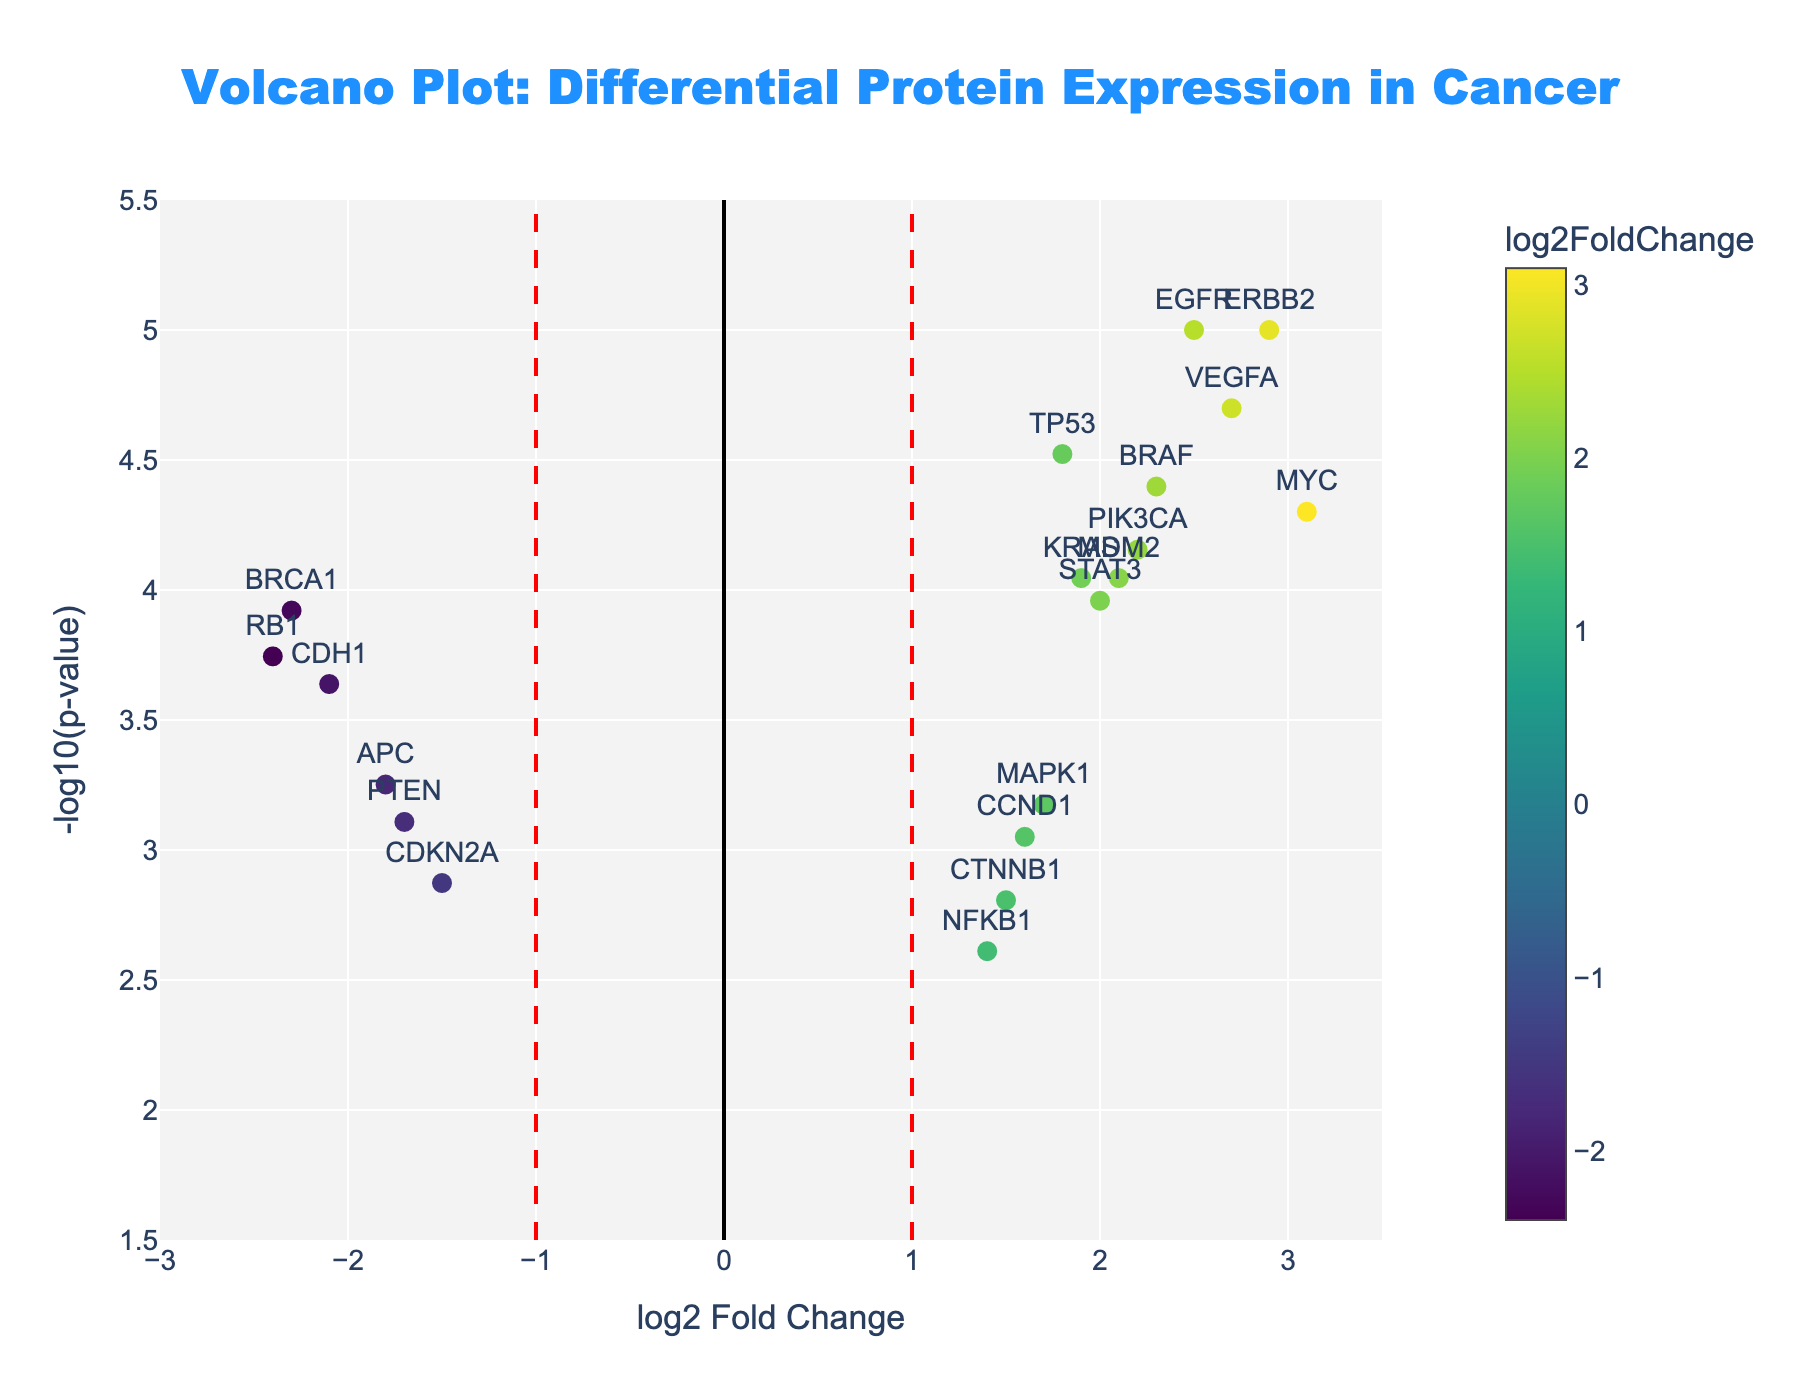What is the title of the figure? The title is typically displayed at the top of the figure. It gives a brief description of what the figure represents. Here, it is provided in the code: "Volcano Plot: Differential Protein Expression in Cancer".
Answer: Volcano Plot: Differential Protein Expression in Cancer How many vertical red dashed lines are in the plot? By looking at the figure, you can see the red dashed lines. According to the code, there are two red dashed vertical lines at x = -1 and x = 1.
Answer: 2 What is the y-axis label in the plot? The y-axis label describes what the y-axis represents. In the code, it is specified as "-log10(p-value)".
Answer: -log10(p-value) Which protein has the highest -log10(p-value)? By inspecting the scatter points, the protein with the highest point on the y-axis is the one with the highest -log10(p-value). According to the data, EGFR has a p-value of 0.00001, which gives the highest -log10(p-value).
Answer: EGFR Which protein has the largest log2FoldChange value? Examine the x-axis to find the protein positioned farthest to the right. MYC has the largest log2FoldChange value of 3.1.
Answer: MYC How many proteins have a log2FoldChange greater than 2? From the data, look for proteins where the log2FoldChange value is more than 2. The proteins are EGFR, MYC, VEGFA, ERBB2, and BRAF.
Answer: 5 Which proteins fall into the significantly downregulated category (log2FoldChange < -1 and -log10(p-value) > 1.3)? To find significantly downregulated proteins, check for those with log2FoldChange less than -1 and -log10(p-value) greater than 1.3 (this corresponds to p-value < 0.05). According to the data, they are BRCA1, PTEN, CDH1, CDKN2A, APC, and RB1.
Answer: BRCA1, PTEN, CDH1, CDKN2A, APC, RB1 What is the -log10(p-value) of PTEN? Find PTEN in the data and use its p-value to compute -log10(p-value). For PTEN, p-value is 0.00078, so -log10(0.00078) approximately equals 3.11.
Answer: 3.11 Which protein exhibits the smallest -log10(p-value) that is still considered significant (below the red horizontal line)? The red horizontal line marks -log10(0.05), which is 1.3. NFKB1 has a -log10(p-value) of about 2.61 (p-value: 0.00245), which is the smallest value above 1.3.
Answer: NFKB1 What is the clear threshold for statistical significance in this plot? The threshold for statistical significance is commonly p-value < 0.05, which translates to -log10(p-value) > 1.3 (as marked by the horizontal red line).
Answer: 1.3 